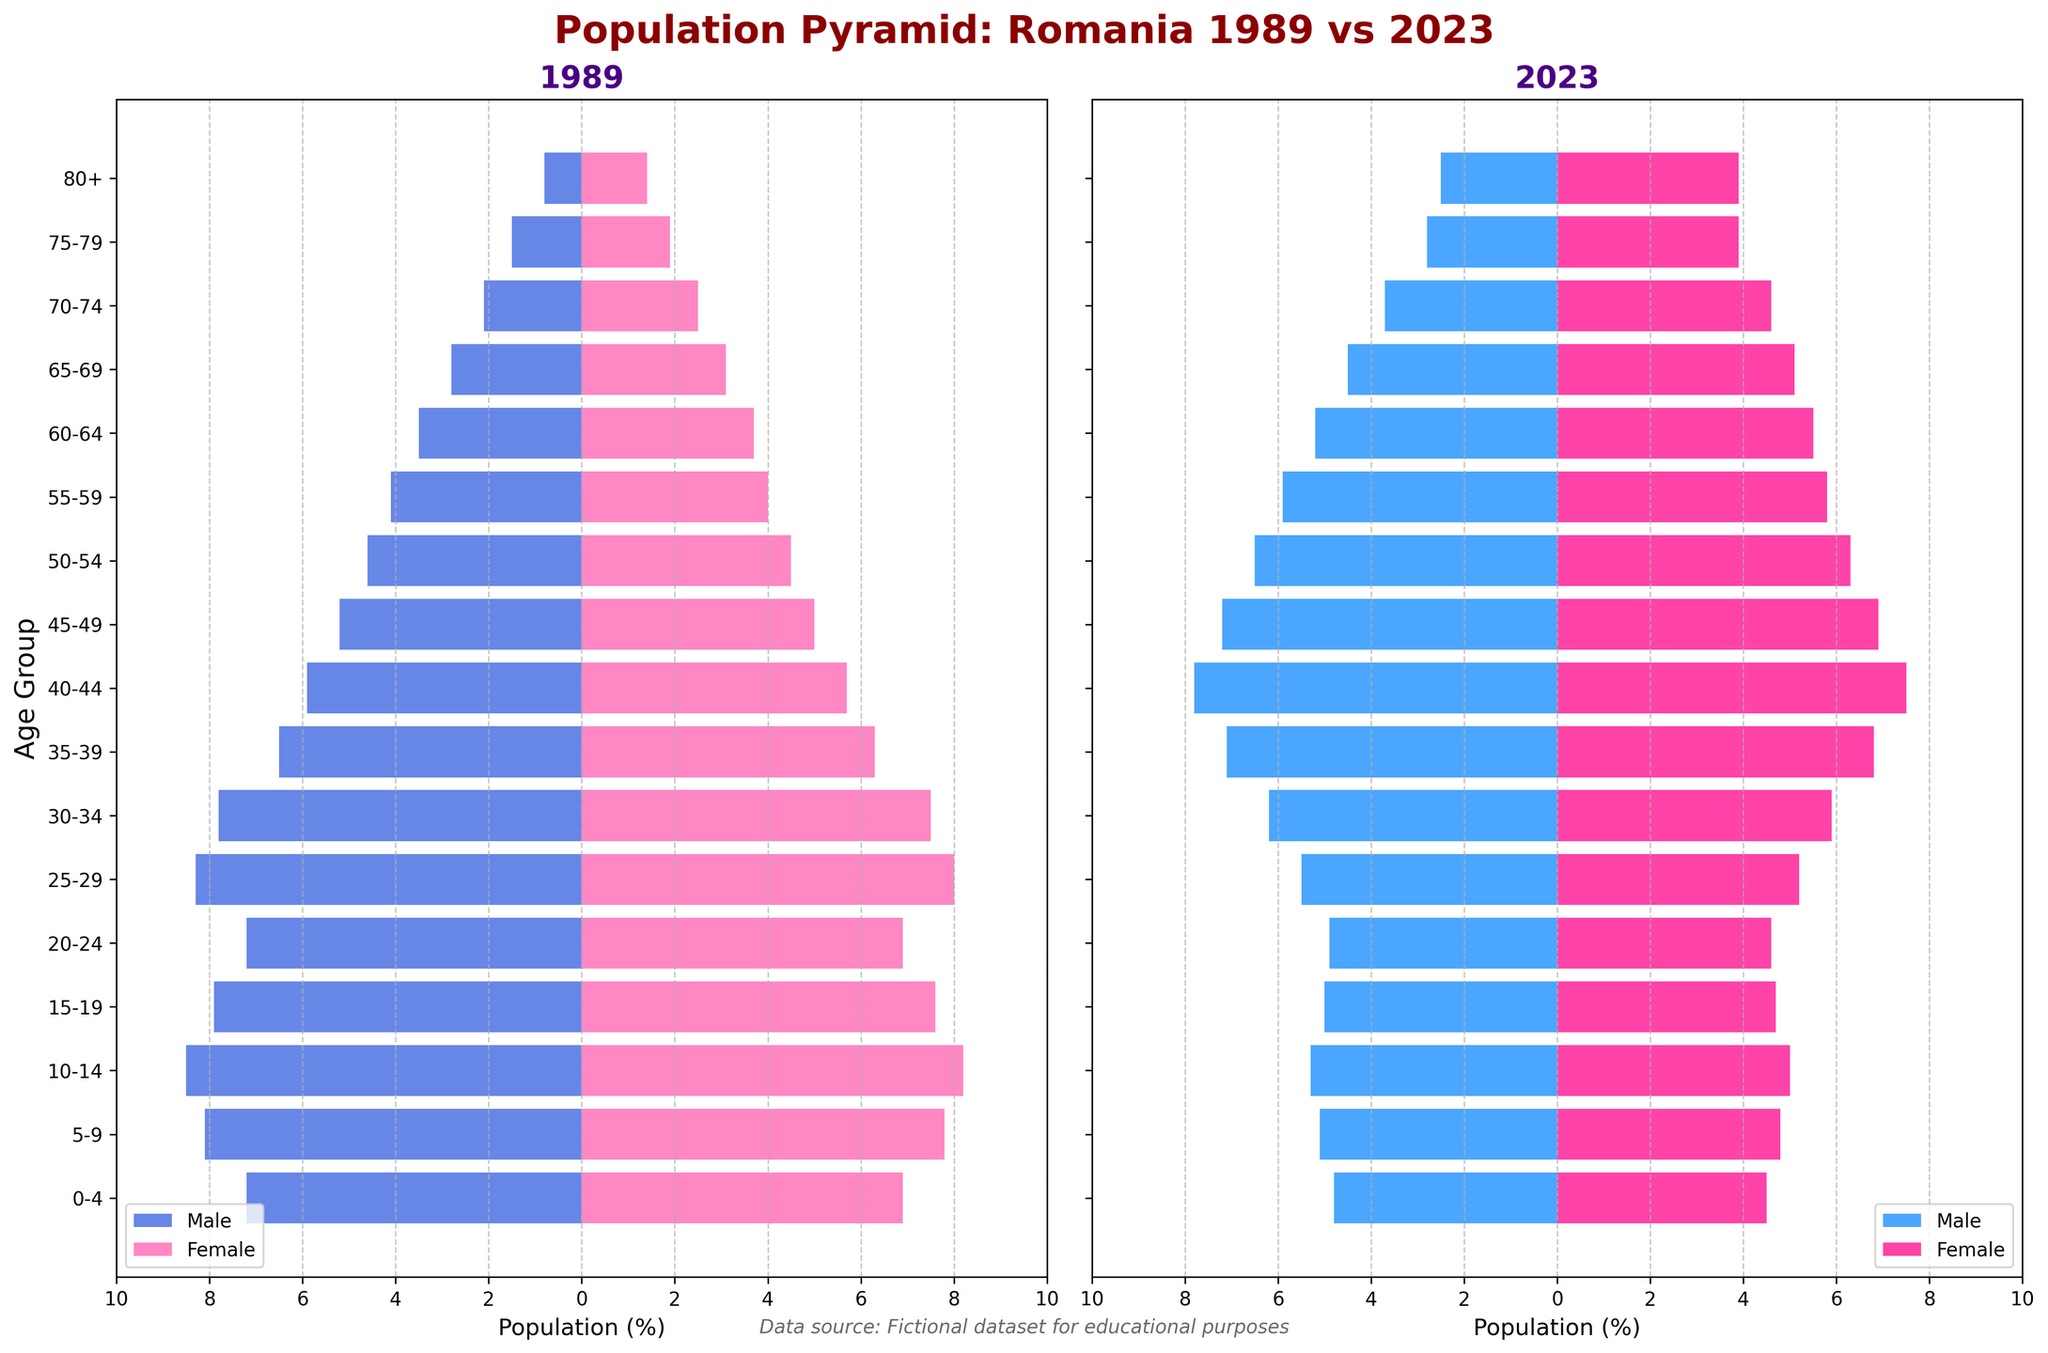Which age group had the largest percentage of males in 1989? Look at the left-hand side of the 1989 population pyramid and identify the age group with the longest bar in the negative direction (representing males).
Answer: 10-14 Which age group had a higher percentage of females in 2023 than in 1989? Compare the two sections on the right-hand side of both the 1989 and 2023 pyramids to identify which age group's female percentage has increased.
Answer: 75-79 What is the approximate difference in percentage between males and females aged 0-4 in 1989? In 1989, males aged 0-4 are around 7.2% and females are around 6.9%. The difference is the absolute value of 7.2 - 6.9.
Answer: 0.3% Which age group had the smallest percentage of males in both 1989 and 2023? Identify the age group with the shortest bars in the negative direction (representing males) in both population pyramids.
Answer: 80+ How does the percentage of people aged 65-69 in 2023 compare to 1989? Compare the lengths of the male and female bars for the age group 65-69 in both the 1989 and 2023 population pyramids.
Answer: Higher in 2023 What is the trend for the percentage of population in the age group 25-29 over the years 1989 and 2023, for both males and females? Compare the percentage bars for age group 25-29 in 1989 and 2023 for both males and females. This requires noting if the percentages have increased or decreased.
Answer: Decreased How does the male population percentage aged 45-49 in 2023 compare with that in 1989? Compare the lengths of the male bars for the age group 45-49 in both the 1989 and 2023 pyramids.
Answer: Higher in 2023 In which year was the percentage of females aged 40-44 higher? Compare the right-hand side of the population pyramid for the age group 40-44 in 1989 and 2023.
Answer: 2023 